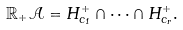Convert formula to latex. <formula><loc_0><loc_0><loc_500><loc_500>\mathbb { R } _ { + } { \mathcal { A } } = H _ { c _ { 1 } } ^ { + } \cap \cdots \cap H _ { c _ { r } } ^ { + } .</formula> 